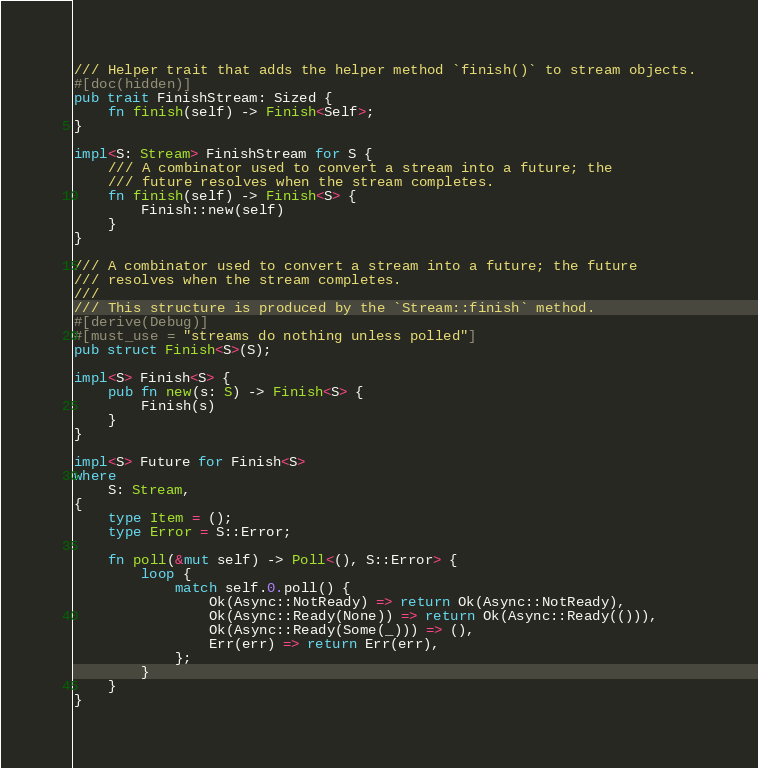<code> <loc_0><loc_0><loc_500><loc_500><_Rust_>/// Helper trait that adds the helper method `finish()` to stream objects.
#[doc(hidden)]
pub trait FinishStream: Sized {
    fn finish(self) -> Finish<Self>;
}

impl<S: Stream> FinishStream for S {
    /// A combinator used to convert a stream into a future; the
    /// future resolves when the stream completes.
    fn finish(self) -> Finish<S> {
        Finish::new(self)
    }
}

/// A combinator used to convert a stream into a future; the future
/// resolves when the stream completes.
///
/// This structure is produced by the `Stream::finish` method.
#[derive(Debug)]
#[must_use = "streams do nothing unless polled"]
pub struct Finish<S>(S);

impl<S> Finish<S> {
    pub fn new(s: S) -> Finish<S> {
        Finish(s)
    }
}

impl<S> Future for Finish<S>
where
    S: Stream,
{
    type Item = ();
    type Error = S::Error;

    fn poll(&mut self) -> Poll<(), S::Error> {
        loop {
            match self.0.poll() {
                Ok(Async::NotReady) => return Ok(Async::NotReady),
                Ok(Async::Ready(None)) => return Ok(Async::Ready(())),
                Ok(Async::Ready(Some(_))) => (),
                Err(err) => return Err(err),
            };
        }
    }
}
</code> 